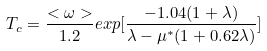<formula> <loc_0><loc_0><loc_500><loc_500>T _ { c } = \frac { < \omega > } { 1 . 2 } e x p [ \frac { - 1 . 0 4 ( 1 + \lambda ) } { \lambda - \mu ^ { * } ( 1 + 0 . 6 2 \lambda ) } ]</formula> 